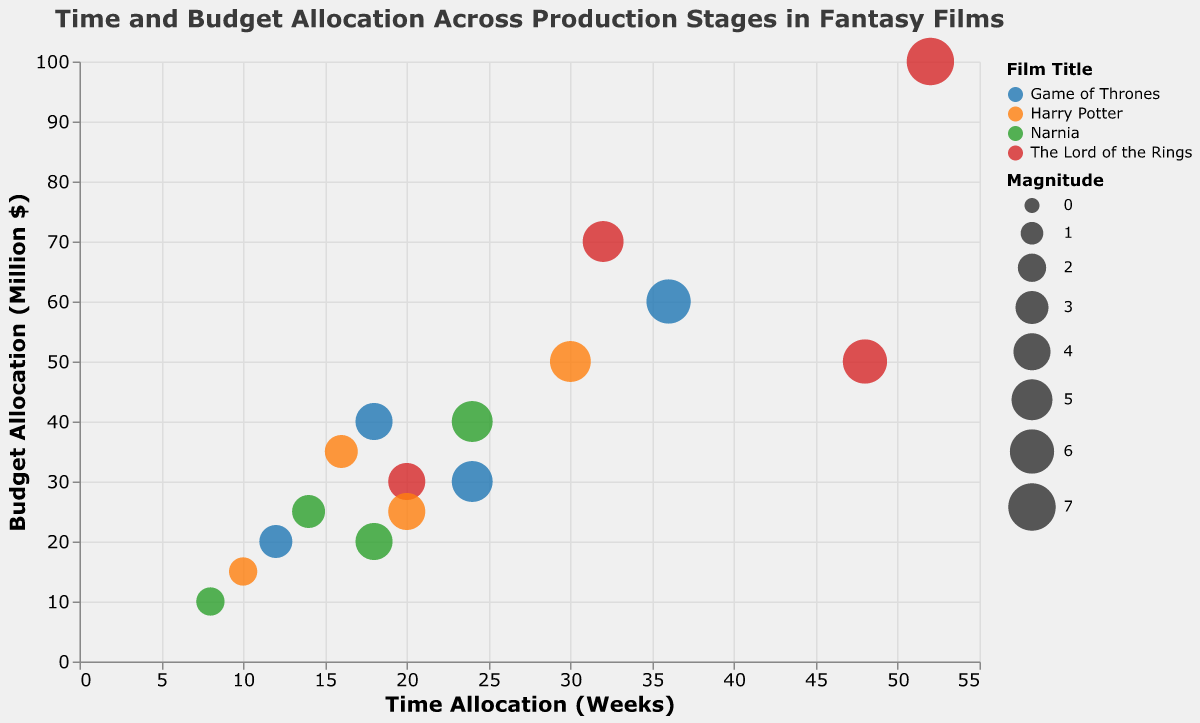Which film has the highest time allocation during the production stage? To determine the film with the highest time allocation during the production stage, look at the "Time Allocation (Weeks)" on the x-axis for the "Production" stage for each film. "The Lord of the Rings" has 52 weeks, which is the highest among all films at the production stage.
Answer: The Lord of the Rings What is the budget allocation for the pre-production stage of "Harry Potter"? Identify "Harry Potter" and find the circle with the "Pre-Production" label. The corresponding y-axis value (budget allocation) for this point is 25 million dollars.
Answer: 25 million dollars Between "Game of Thrones" and "Narnia," which film has a higher magnitude during the post-production stage? Find the points corresponding to the "Post-Production" stage for both "Game of Thrones" and "Narnia." "Game of Thrones" has a magnitude of 4, while "Narnia" has a magnitude of 3.
Answer: Game of Thrones What is the difference in budget allocation between the marketing stages of "The Lord of the Rings" and "Harry Potter"? For "The Lord of the Rings" marketing stage, the budget is 30 million dollars. For "Harry Potter," it is 15 million dollars. The difference is 30 - 15 = 15 million dollars.
Answer: 15 million dollars Which production stage has the highest average time allocation across all films? Calculate the average time allocation for each stage by summing the times and dividing by the number of films. Pre-Production: (24+48+20+18)/4 = 27.5 weeks, Production: (36+52+30+24)/4 = 35.5 weeks, Post-Production: (18+32+16+14)/4 = 20 weeks, Marketing: (12+20+10+8)/4 = 12.5 weeks. The Production stage has the highest average time allocation of 35.5 weeks.
Answer: Production Comparing "Harry Potter" and "Narnia," which film has a shorter total time allocation across all stages? Sum the time allocation for each stage for both films. "Harry Potter": Pre-Production (20) + Production (30) + Post-Production (16) + Marketing (10) = 76 weeks. "Narnia": Pre-Production (18) + Production (24) + Post-Production (14) + Marketing (8) = 64 weeks. "Narnia" has the shorter total time allocation.
Answer: Narnia 